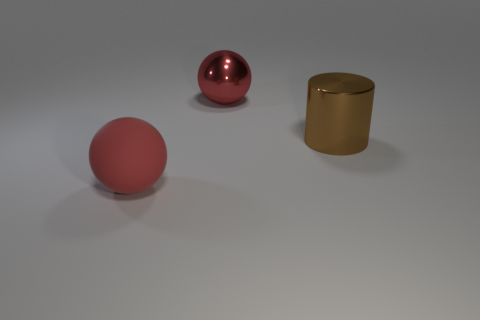There is a big metallic sphere; does it have the same color as the big thing that is in front of the big brown object? The large metallic sphere has a glossy red hue that is distinct from the matte gold color of the cylindrical object situated in front of the large brown cube. 